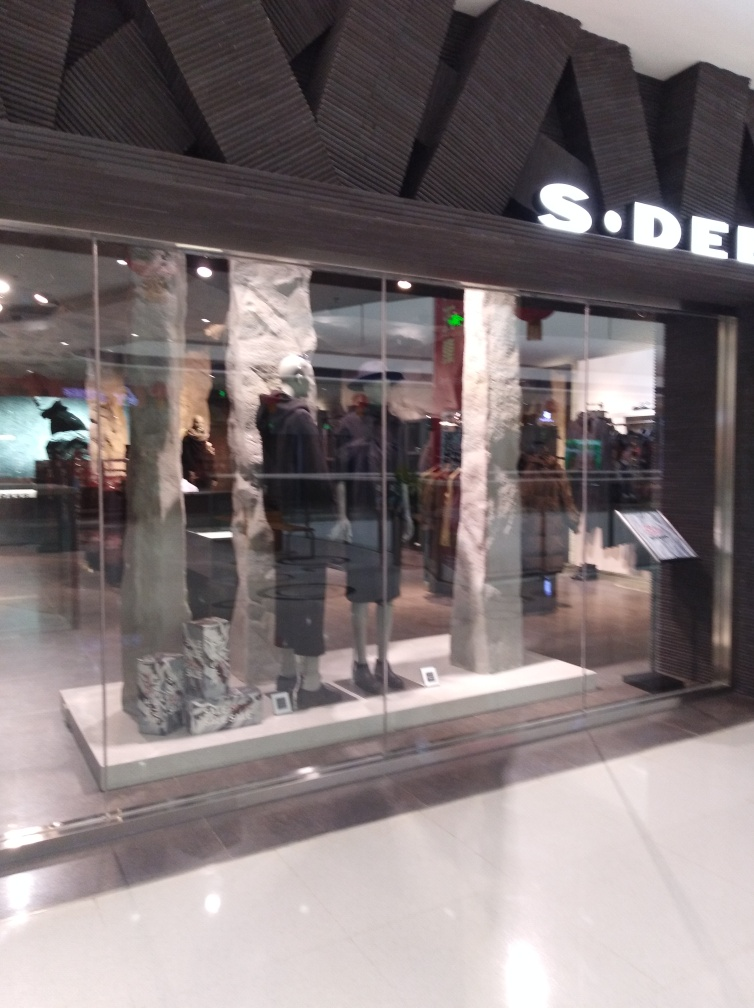What kind of items are displayed in the window of this store? The window display features a range of fashion items, including clothing and accessories strategically presented to attract potential customers. Can you describe the style of clothing? The style of clothing appears to be contemporary and trendy, indicating the store likely caters to modern fashion sensibilities. 